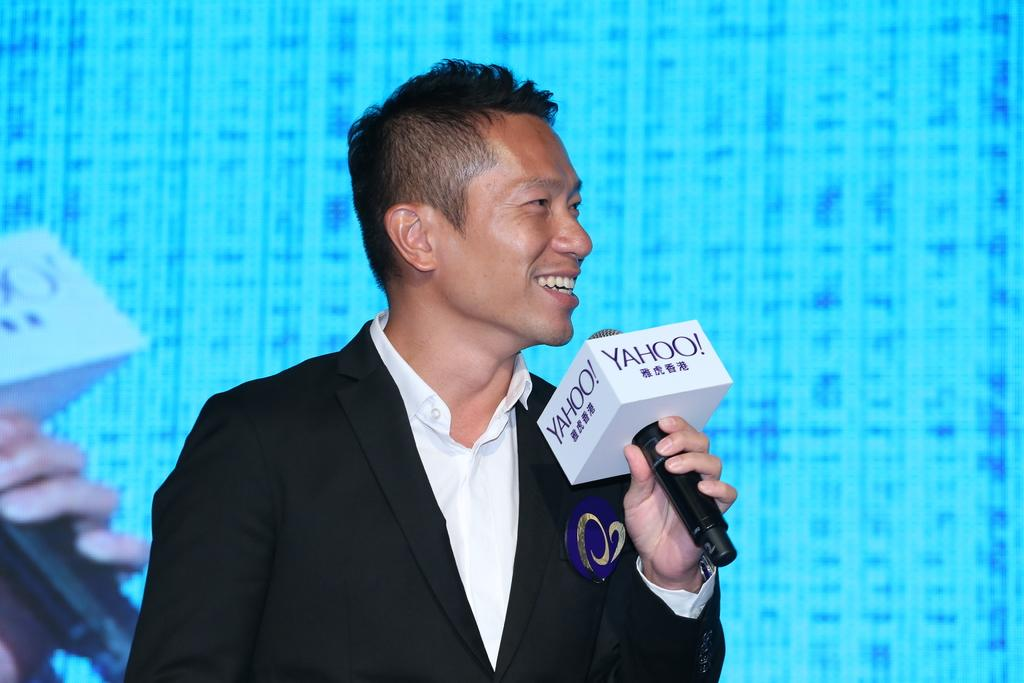What is the person in the image doing? The person is holding a microphone in the image. What is the person's facial expression in the image? The person is smiling in the image. What can be seen in the background of the image? There is a screen in the background of the image. What body part is visible in the image? Human fingers are visible in the image. What color scheme is present in the image? There are black and white color objects in the image. What type of balls are visible in the image? There are no balls present in the image. What month is depicted in the image? The image does not depict a specific month; it features a person holding a microphone and other objects. 